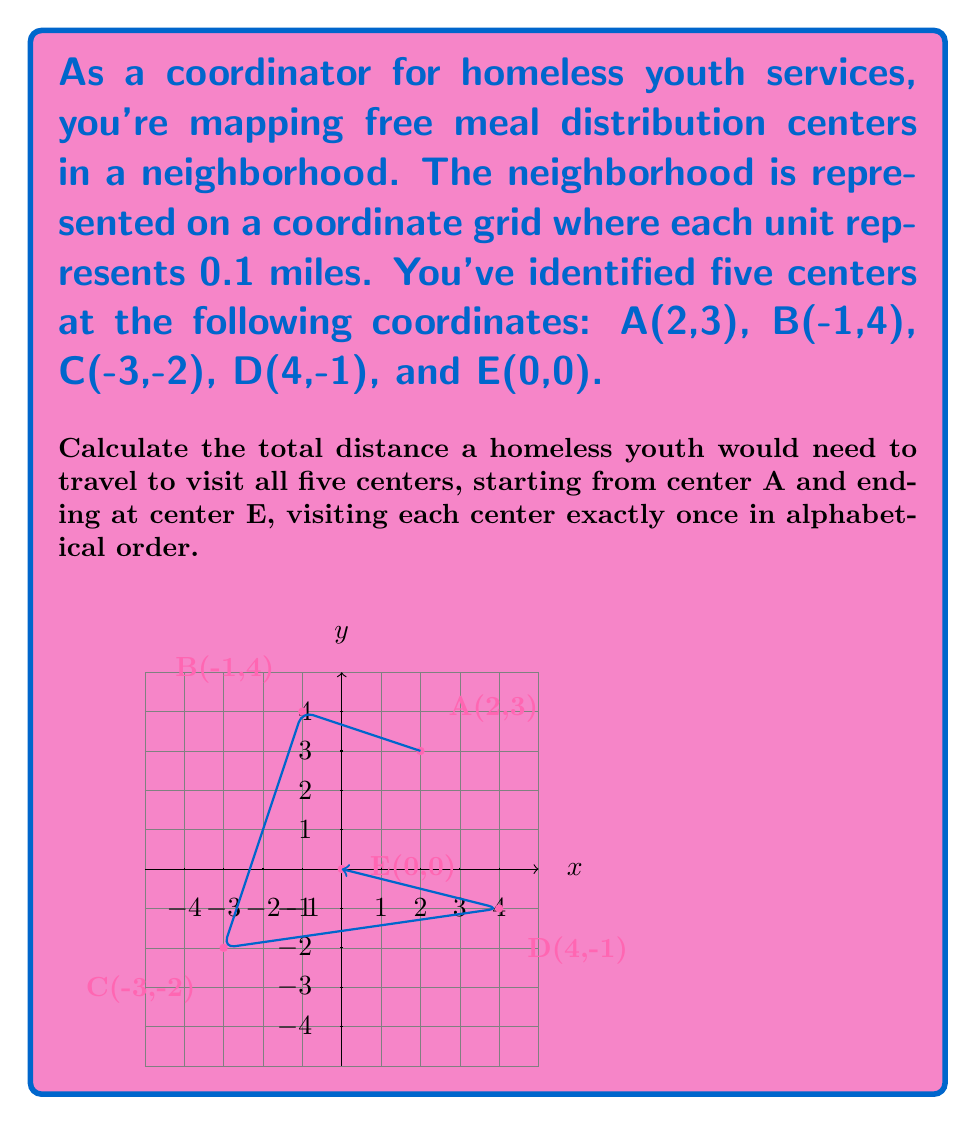What is the answer to this math problem? Let's approach this step-by-step:

1) To calculate the distance between two points, we use the distance formula:
   $$d = \sqrt{(x_2-x_1)^2 + (y_2-y_1)^2}$$

2) Calculate distance from A to B:
   $$d_{AB} = \sqrt{(-1-2)^2 + (4-3)^2} = \sqrt{(-3)^2 + 1^2} = \sqrt{10}$$

3) Calculate distance from B to C:
   $$d_{BC} = \sqrt{(-3-(-1))^2 + (-2-4)^2} = \sqrt{(-2)^2 + (-6)^2} = \sqrt{40}$$

4) Calculate distance from C to D:
   $$d_{CD} = \sqrt{(4-(-3))^2 + (-1-(-2))^2} = \sqrt{7^2 + 1^2} = \sqrt{50}$$

5) Calculate distance from D to E:
   $$d_{DE} = \sqrt{(0-4)^2 + (0-(-1))^2} = \sqrt{(-4)^2 + 1^2} = \sqrt{17}$$

6) Sum up all distances:
   $$d_{total} = \sqrt{10} + \sqrt{40} + \sqrt{50} + \sqrt{17}$$

7) Simplify:
   $$d_{total} = \sqrt{10} + 2\sqrt{10} + 5\sqrt{2} + \sqrt{17}$$

8) Convert to miles:
   $$d_{miles} = 0.1 \times (\sqrt{10} + 2\sqrt{10} + 5\sqrt{2} + \sqrt{17})$$
Answer: $0.1 \times (\sqrt{10} + 2\sqrt{10} + 5\sqrt{2} + \sqrt{17})$ miles 